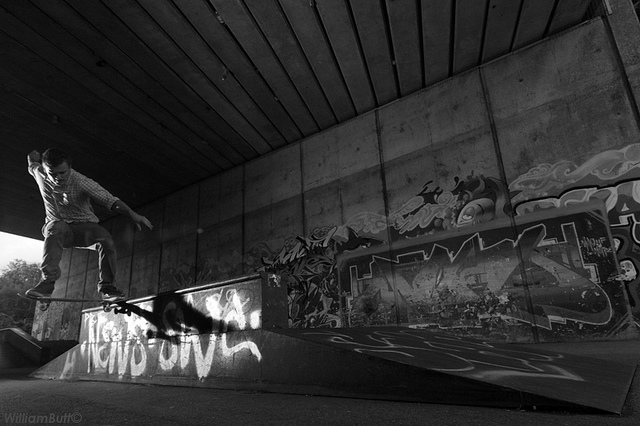<image>What color is the skaters hat? The skater is not wearing a hat in the image. What color is the skaters hat? I don't know what color the skater's hat is. It can be seen black or the skater may not be wearing a hat. 